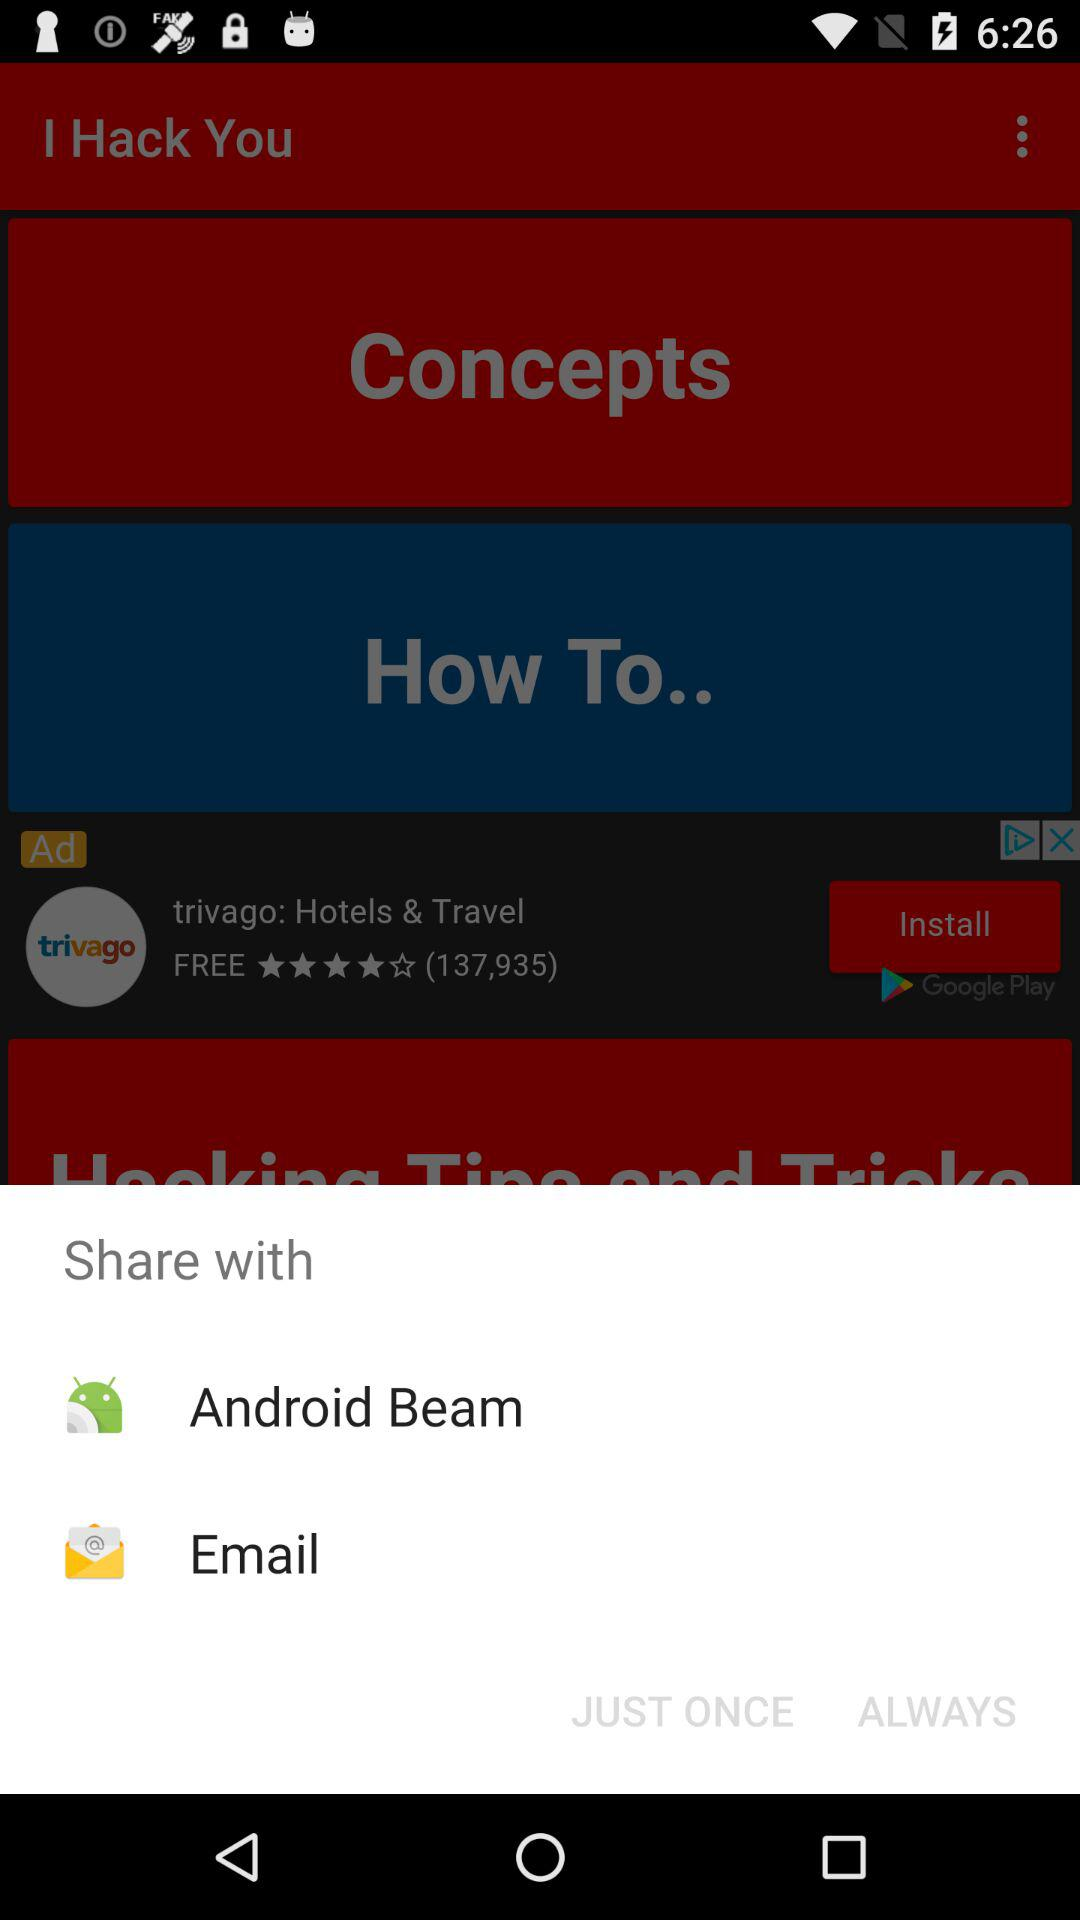What are the different options available for sharing? The different options available for sharing are "Android Beam" and "Email". 